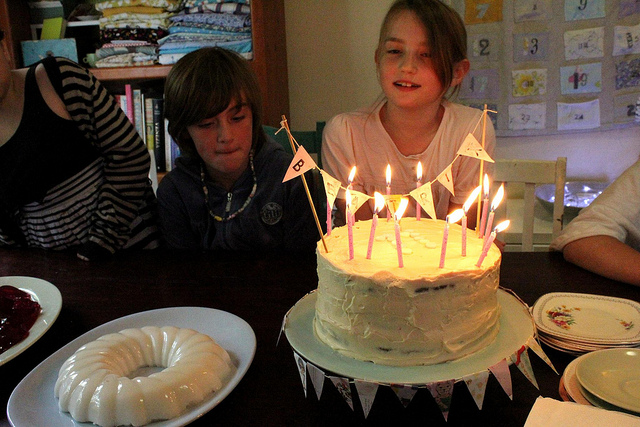Tell me more about the environment where this celebration is taking place. The image suggests a cozy indoor setting, possibly a family home, with personal items and decorations in the background, creating an intimate atmosphere for the celebration. 